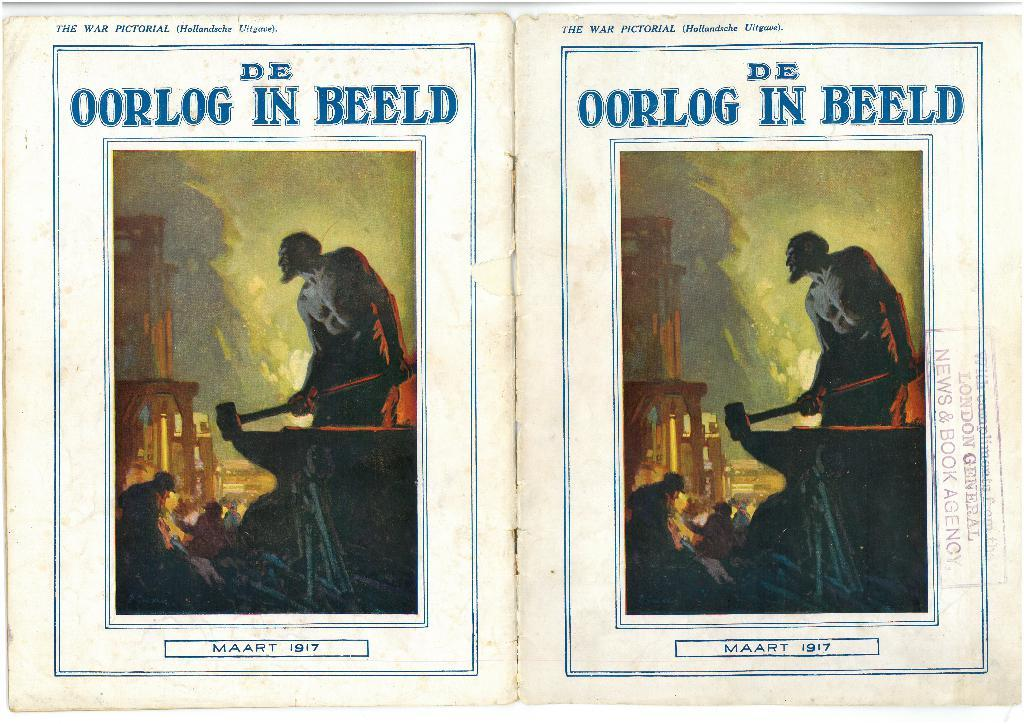<image>
Summarize the visual content of the image. Two images that are a cover of a book that reads De Oorlog in Beeld. 